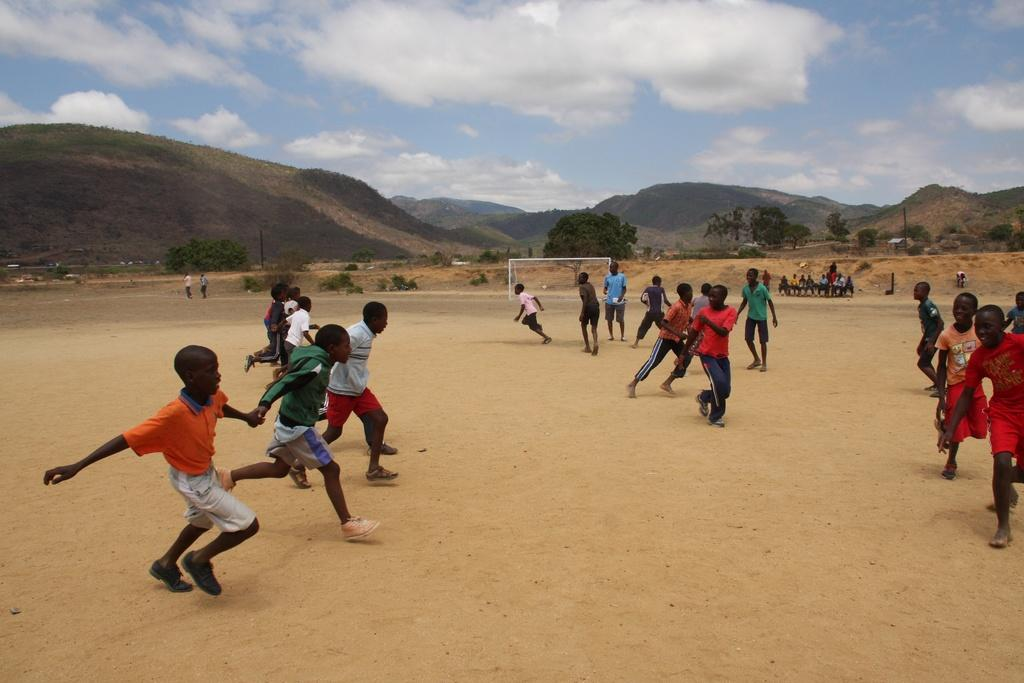How many people are in the image? There are a few people in the image. What is visible beneath the people's feet in the image? The ground is visible in the image. What object is present in the image that is typically used for separating or dividing areas? There is a net in the image. What type of vegetation can be seen in the image? There are plants and trees in the image. What geographical feature is visible in the image? There are hills in the image. What is visible at the top of the image? The sky is visible in the image, and there are clouds in the sky. What type of cub can be seen playing with a stone in the image? There is no cub or stone present in the image. What type of work are the people in the image engaged in? The image does not provide any information about the people's work or occupation. 